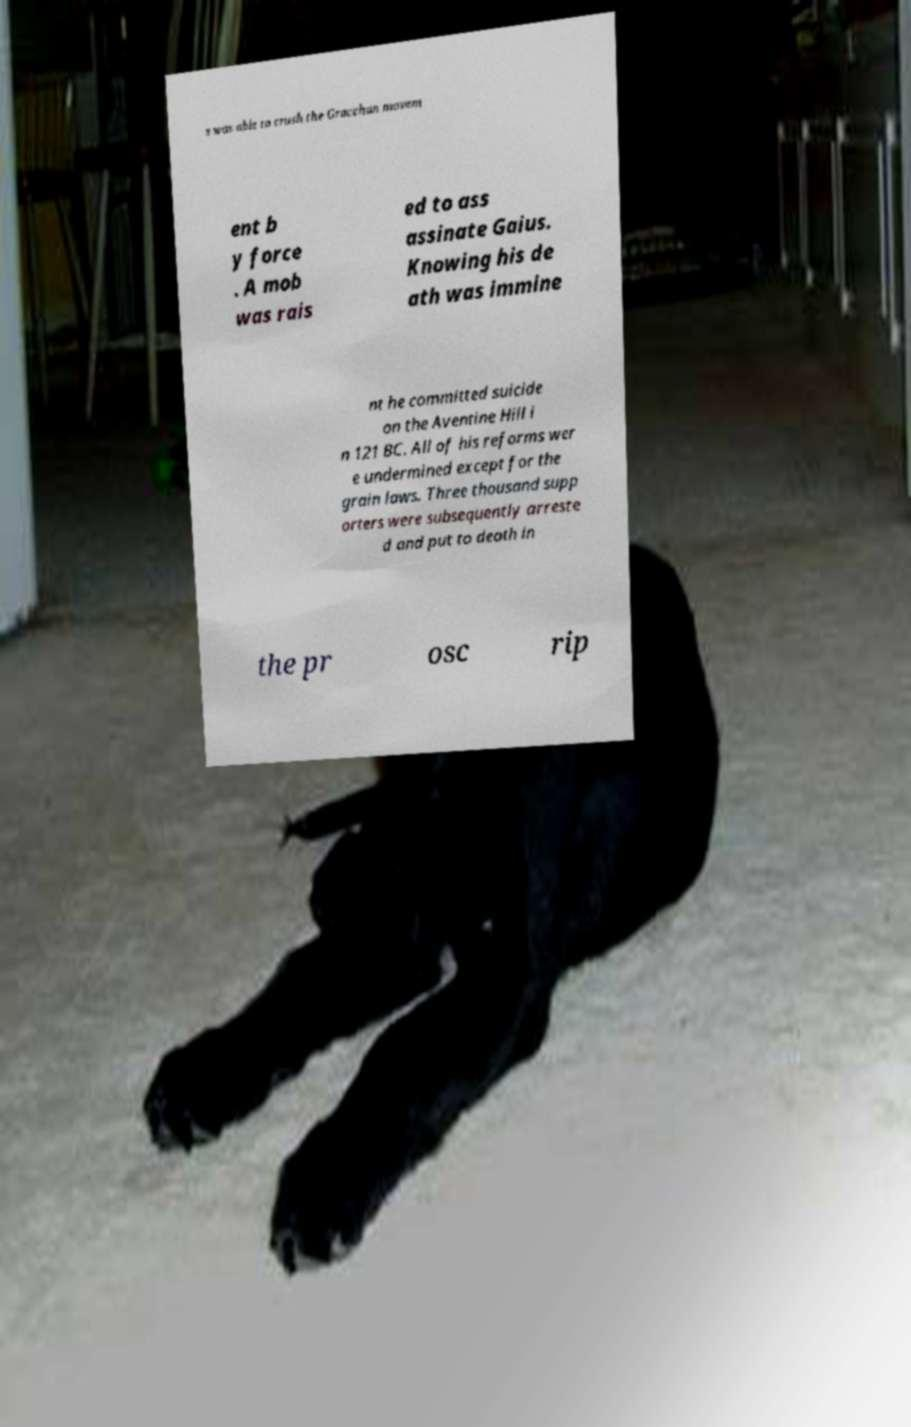I need the written content from this picture converted into text. Can you do that? s was able to crush the Gracchan movem ent b y force . A mob was rais ed to ass assinate Gaius. Knowing his de ath was immine nt he committed suicide on the Aventine Hill i n 121 BC. All of his reforms wer e undermined except for the grain laws. Three thousand supp orters were subsequently arreste d and put to death in the pr osc rip 